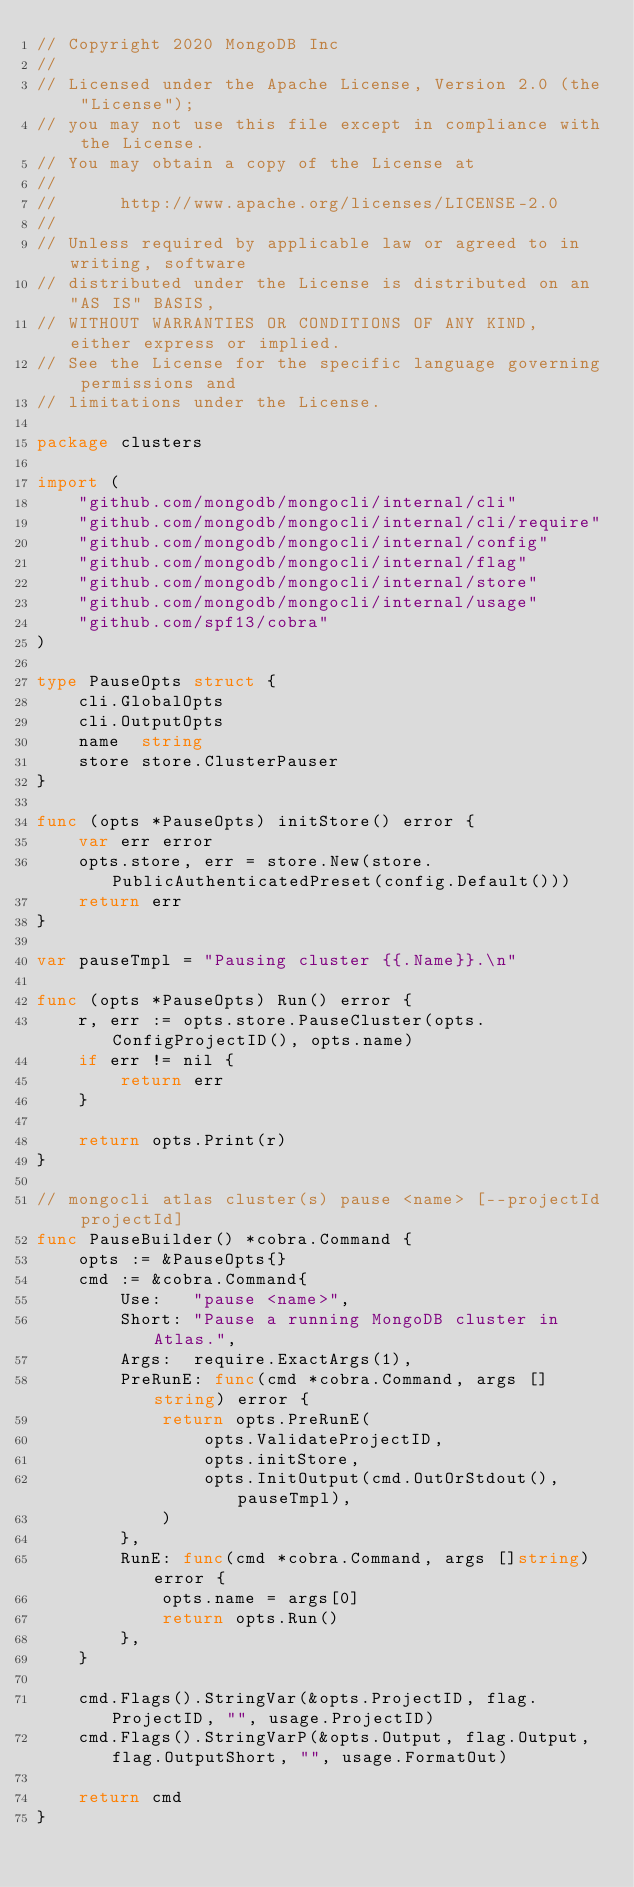<code> <loc_0><loc_0><loc_500><loc_500><_Go_>// Copyright 2020 MongoDB Inc
//
// Licensed under the Apache License, Version 2.0 (the "License");
// you may not use this file except in compliance with the License.
// You may obtain a copy of the License at
//
//      http://www.apache.org/licenses/LICENSE-2.0
//
// Unless required by applicable law or agreed to in writing, software
// distributed under the License is distributed on an "AS IS" BASIS,
// WITHOUT WARRANTIES OR CONDITIONS OF ANY KIND, either express or implied.
// See the License for the specific language governing permissions and
// limitations under the License.

package clusters

import (
	"github.com/mongodb/mongocli/internal/cli"
	"github.com/mongodb/mongocli/internal/cli/require"
	"github.com/mongodb/mongocli/internal/config"
	"github.com/mongodb/mongocli/internal/flag"
	"github.com/mongodb/mongocli/internal/store"
	"github.com/mongodb/mongocli/internal/usage"
	"github.com/spf13/cobra"
)

type PauseOpts struct {
	cli.GlobalOpts
	cli.OutputOpts
	name  string
	store store.ClusterPauser
}

func (opts *PauseOpts) initStore() error {
	var err error
	opts.store, err = store.New(store.PublicAuthenticatedPreset(config.Default()))
	return err
}

var pauseTmpl = "Pausing cluster {{.Name}}.\n"

func (opts *PauseOpts) Run() error {
	r, err := opts.store.PauseCluster(opts.ConfigProjectID(), opts.name)
	if err != nil {
		return err
	}

	return opts.Print(r)
}

// mongocli atlas cluster(s) pause <name> [--projectId projectId]
func PauseBuilder() *cobra.Command {
	opts := &PauseOpts{}
	cmd := &cobra.Command{
		Use:   "pause <name>",
		Short: "Pause a running MongoDB cluster in Atlas.",
		Args:  require.ExactArgs(1),
		PreRunE: func(cmd *cobra.Command, args []string) error {
			return opts.PreRunE(
				opts.ValidateProjectID,
				opts.initStore,
				opts.InitOutput(cmd.OutOrStdout(), pauseTmpl),
			)
		},
		RunE: func(cmd *cobra.Command, args []string) error {
			opts.name = args[0]
			return opts.Run()
		},
	}

	cmd.Flags().StringVar(&opts.ProjectID, flag.ProjectID, "", usage.ProjectID)
	cmd.Flags().StringVarP(&opts.Output, flag.Output, flag.OutputShort, "", usage.FormatOut)

	return cmd
}
</code> 